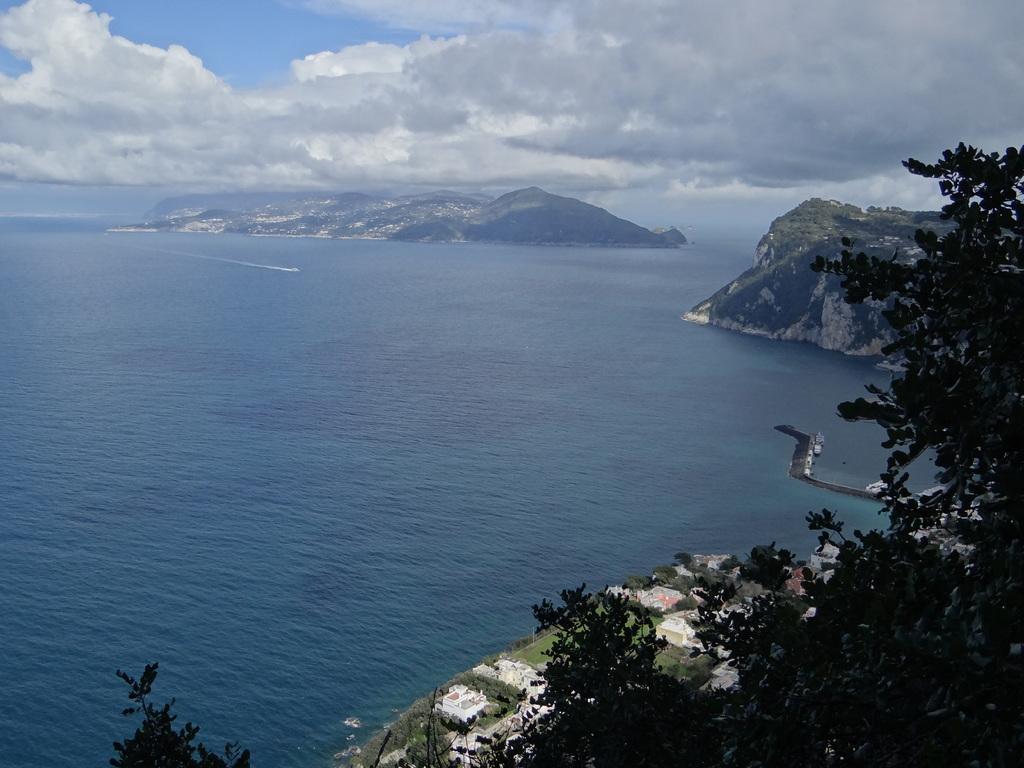Can you describe this image briefly? This is an outside view. Here I can see an ocean. On the right side, I can see some trees and buildings. In the background there are hills. At the top of the image I can see the sky and clouds. 